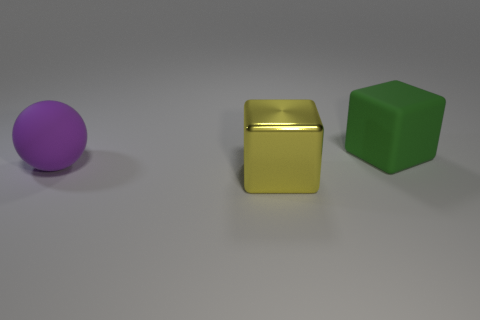Add 3 small green shiny things. How many objects exist? 6 Subtract all balls. How many objects are left? 2 Subtract 0 blue blocks. How many objects are left? 3 Subtract all big brown metal cylinders. Subtract all green rubber blocks. How many objects are left? 2 Add 1 big green matte objects. How many big green matte objects are left? 2 Add 1 small yellow metallic objects. How many small yellow metallic objects exist? 1 